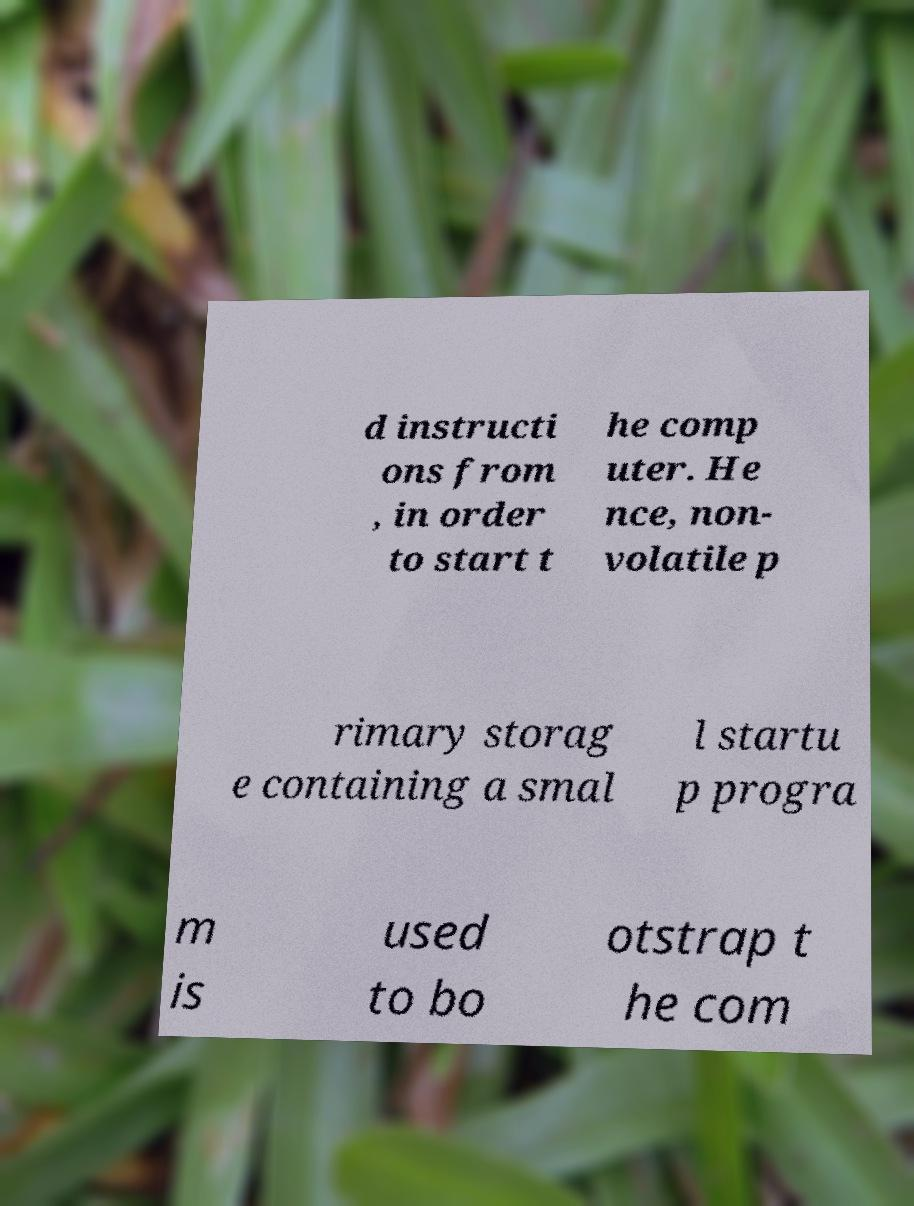Could you assist in decoding the text presented in this image and type it out clearly? d instructi ons from , in order to start t he comp uter. He nce, non- volatile p rimary storag e containing a smal l startu p progra m is used to bo otstrap t he com 